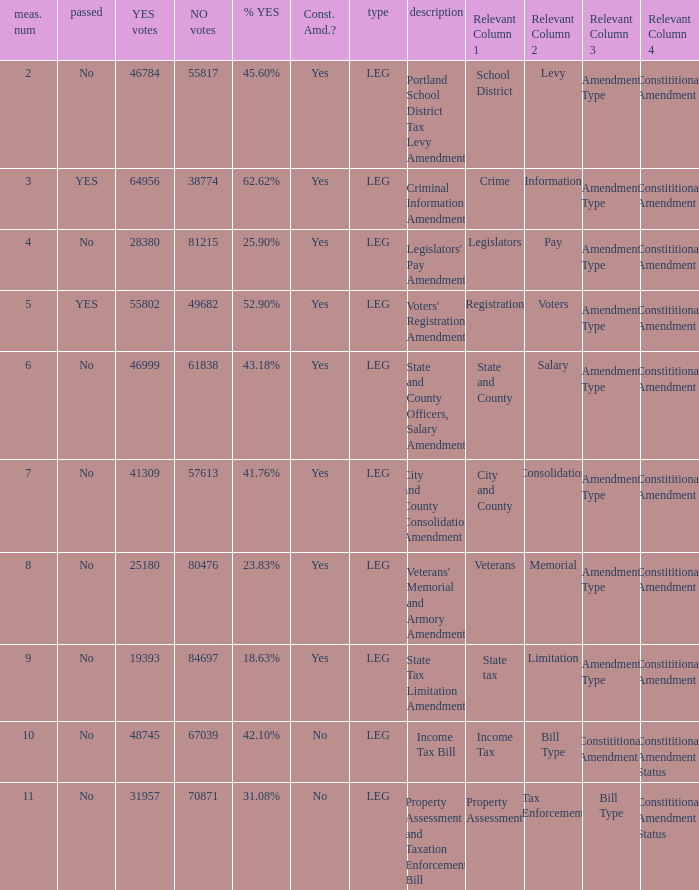How many yes votes made up 43.18% yes? 46999.0. 